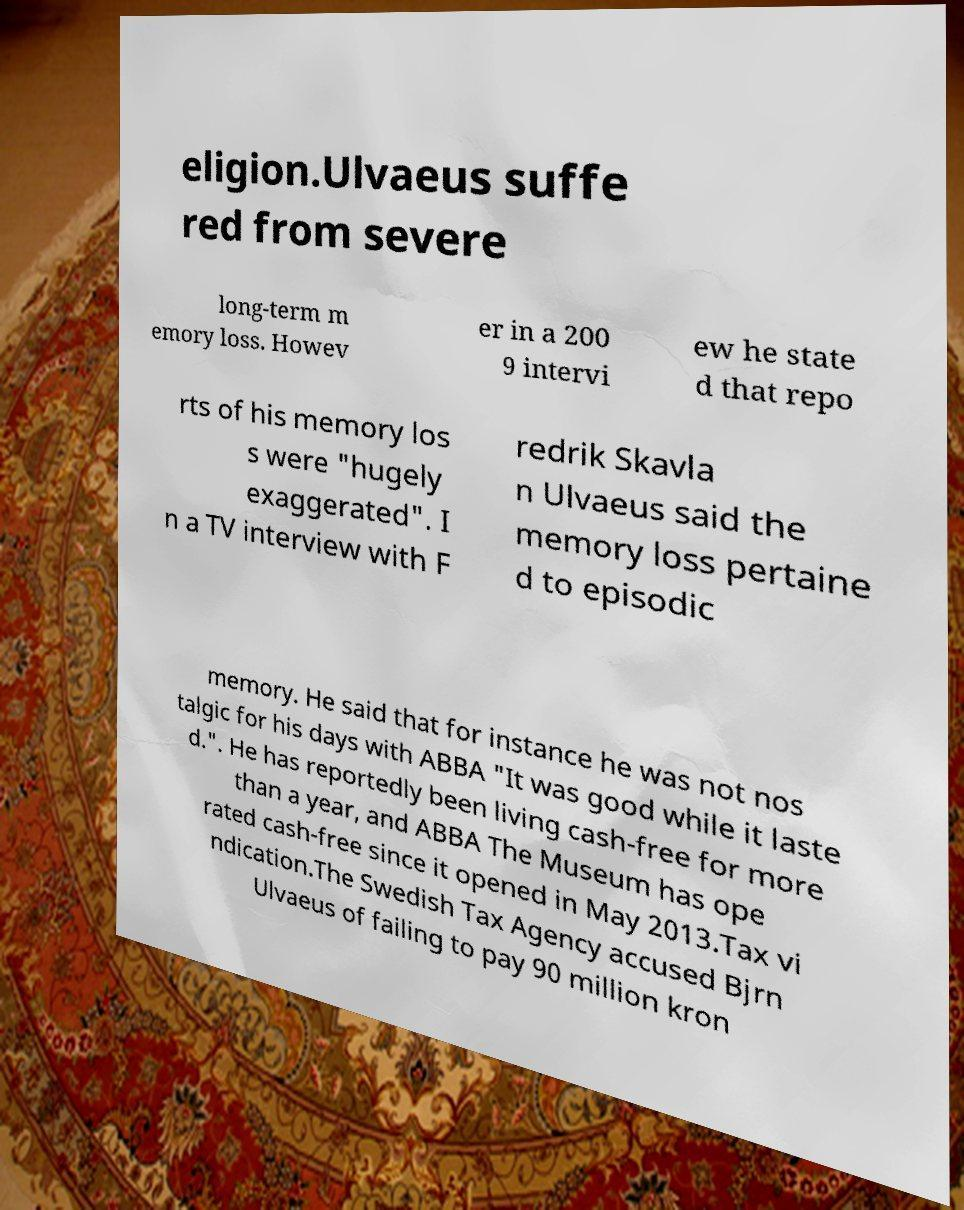Please identify and transcribe the text found in this image. eligion.Ulvaeus suffe red from severe long-term m emory loss. Howev er in a 200 9 intervi ew he state d that repo rts of his memory los s were "hugely exaggerated". I n a TV interview with F redrik Skavla n Ulvaeus said the memory loss pertaine d to episodic memory. He said that for instance he was not nos talgic for his days with ABBA "It was good while it laste d.". He has reportedly been living cash-free for more than a year, and ABBA The Museum has ope rated cash-free since it opened in May 2013.Tax vi ndication.The Swedish Tax Agency accused Bjrn Ulvaeus of failing to pay 90 million kron 